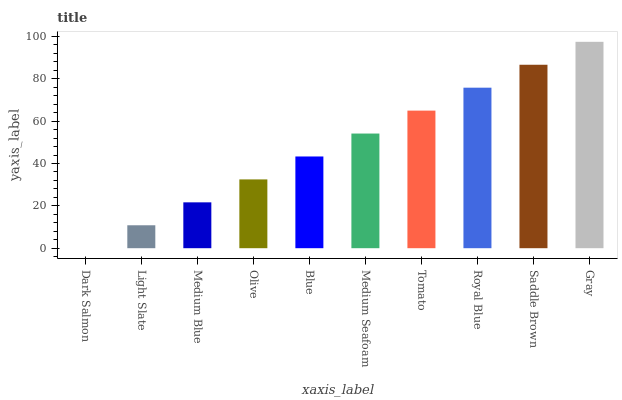Is Dark Salmon the minimum?
Answer yes or no. Yes. Is Gray the maximum?
Answer yes or no. Yes. Is Light Slate the minimum?
Answer yes or no. No. Is Light Slate the maximum?
Answer yes or no. No. Is Light Slate greater than Dark Salmon?
Answer yes or no. Yes. Is Dark Salmon less than Light Slate?
Answer yes or no. Yes. Is Dark Salmon greater than Light Slate?
Answer yes or no. No. Is Light Slate less than Dark Salmon?
Answer yes or no. No. Is Medium Seafoam the high median?
Answer yes or no. Yes. Is Blue the low median?
Answer yes or no. Yes. Is Dark Salmon the high median?
Answer yes or no. No. Is Medium Blue the low median?
Answer yes or no. No. 